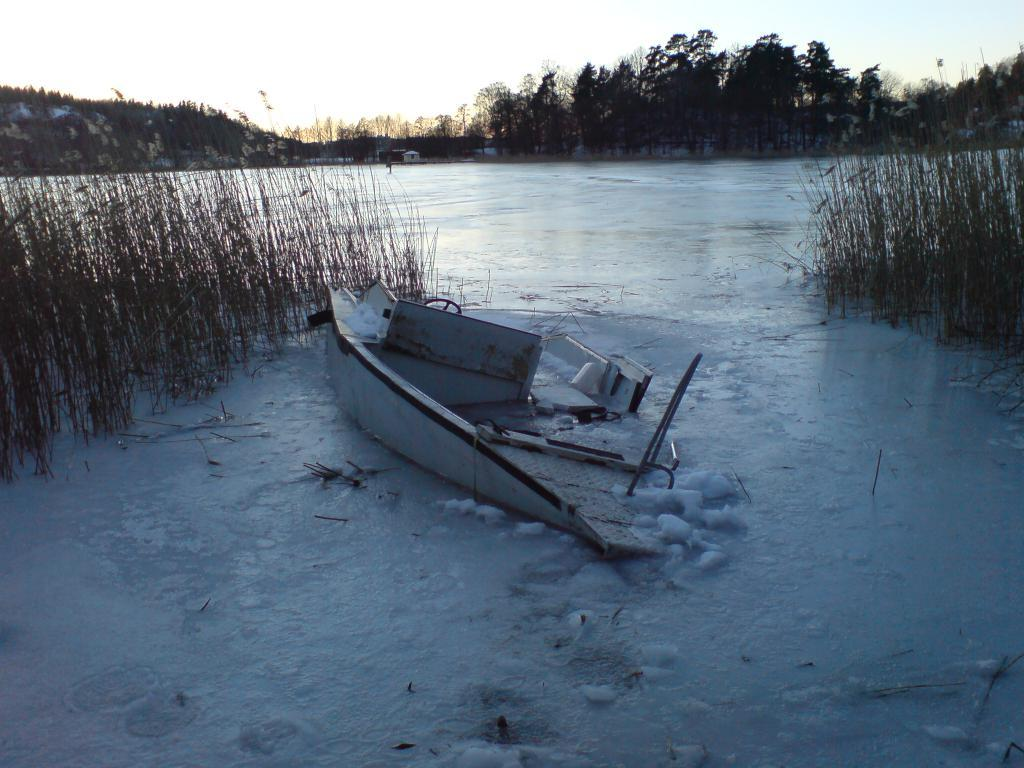What is the main subject of the image? The main subject of the image is a boat. What is present in the boat? There is ice in the image. What other elements can be seen in the image besides the boat and ice? There are plants and trees in the background of the image, as well as houses. What is the condition of the sky in the image? The sky is clear and visible at the top of the image. What color is the jelly that is being used to decorate the boat in the image? There is no jelly present in the image, and therefore no such decoration can be observed. 